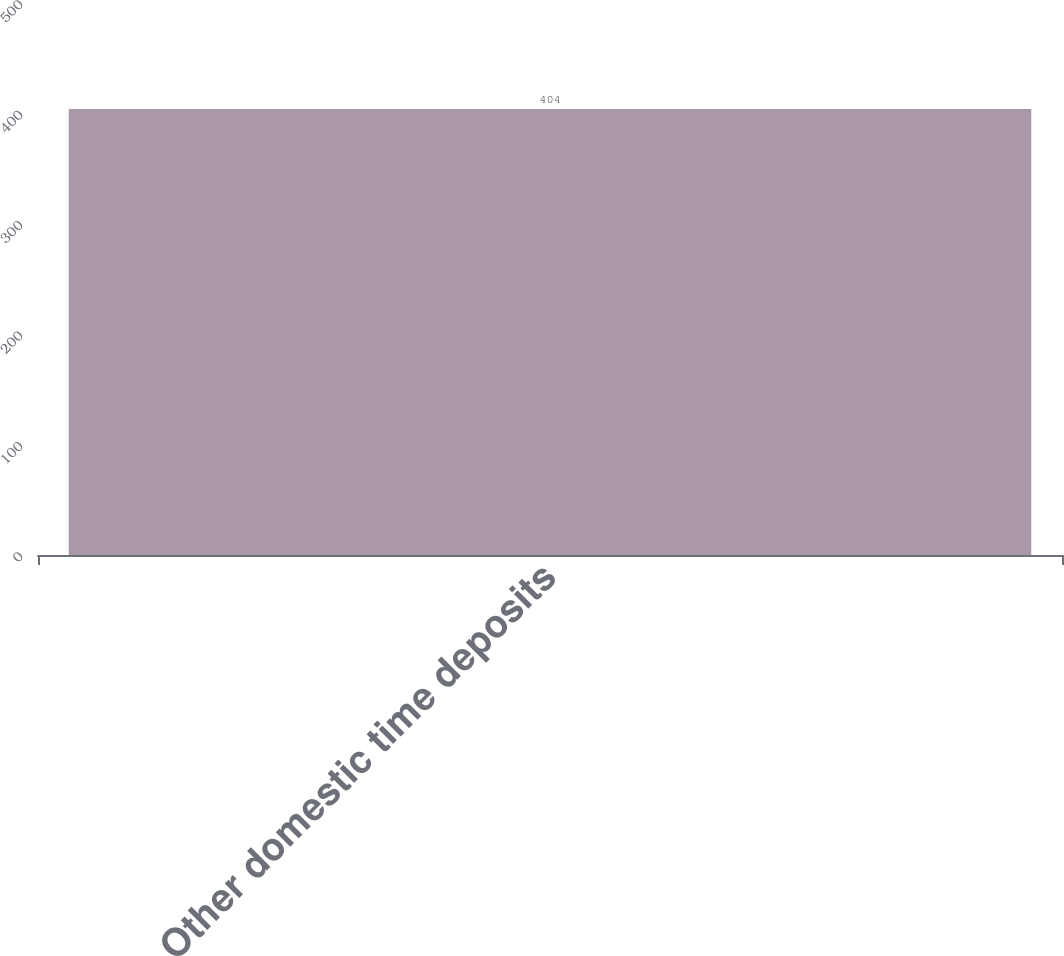<chart> <loc_0><loc_0><loc_500><loc_500><bar_chart><fcel>Other domestic time deposits<nl><fcel>404<nl></chart> 